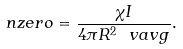<formula> <loc_0><loc_0><loc_500><loc_500>\ n z e r o = \frac { \chi I } { 4 \pi R ^ { 2 } \ v a v g } .</formula> 